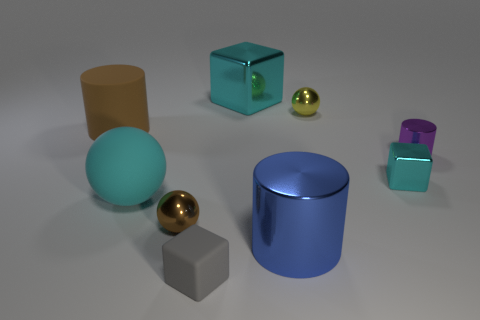Subtract all tiny cubes. How many cubes are left? 1 Subtract 1 spheres. How many spheres are left? 2 Add 1 small blue blocks. How many objects exist? 10 Subtract all cylinders. How many objects are left? 6 Add 3 large yellow metallic cylinders. How many large yellow metallic cylinders exist? 3 Subtract 1 brown cylinders. How many objects are left? 8 Subtract all green metallic cubes. Subtract all cyan metallic objects. How many objects are left? 7 Add 7 tiny rubber cubes. How many tiny rubber cubes are left? 8 